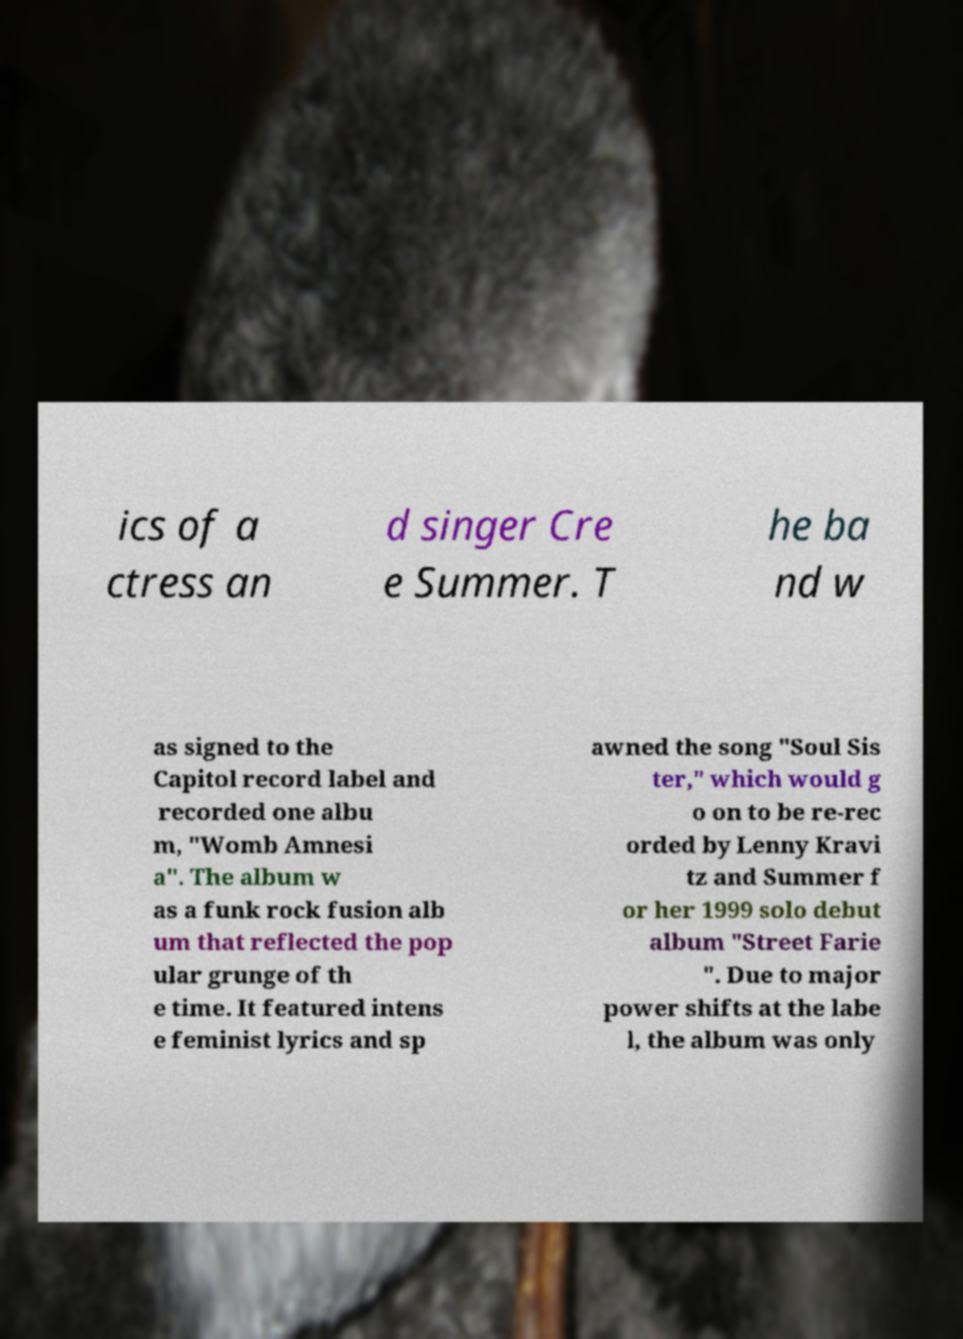There's text embedded in this image that I need extracted. Can you transcribe it verbatim? ics of a ctress an d singer Cre e Summer. T he ba nd w as signed to the Capitol record label and recorded one albu m, "Womb Amnesi a". The album w as a funk rock fusion alb um that reflected the pop ular grunge of th e time. It featured intens e feminist lyrics and sp awned the song "Soul Sis ter," which would g o on to be re-rec orded by Lenny Kravi tz and Summer f or her 1999 solo debut album "Street Farie ". Due to major power shifts at the labe l, the album was only 